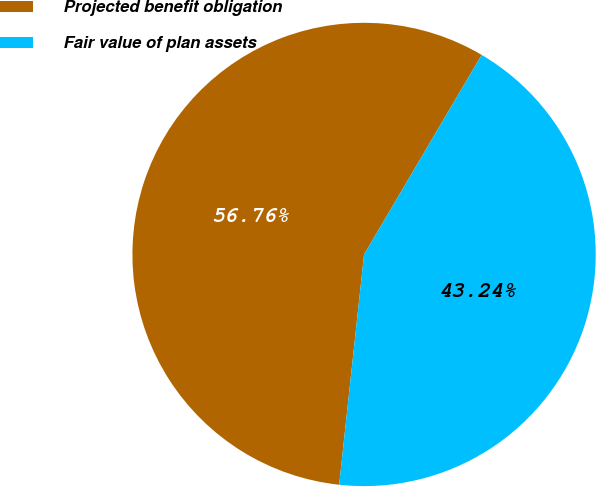Convert chart to OTSL. <chart><loc_0><loc_0><loc_500><loc_500><pie_chart><fcel>Projected benefit obligation<fcel>Fair value of plan assets<nl><fcel>56.76%<fcel>43.24%<nl></chart> 